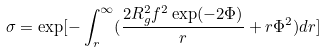<formula> <loc_0><loc_0><loc_500><loc_500>\sigma = \exp [ - \int _ { r } ^ { \infty } ( \frac { 2 R _ { g } ^ { 2 } f ^ { 2 } \exp ( - 2 \Phi ) } { r } + r \Phi ^ { 2 } ) d r ]</formula> 